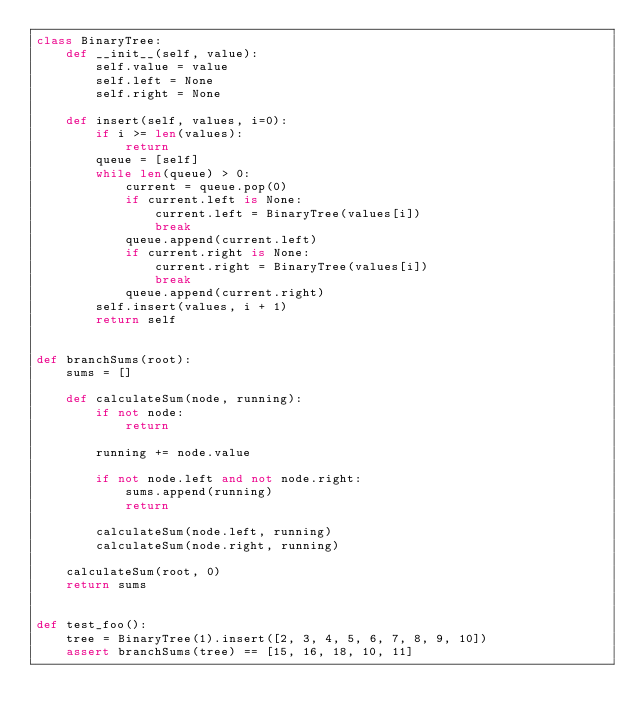Convert code to text. <code><loc_0><loc_0><loc_500><loc_500><_Python_>class BinaryTree:
    def __init__(self, value):
        self.value = value
        self.left = None
        self.right = None

    def insert(self, values, i=0):
        if i >= len(values):
            return
        queue = [self]
        while len(queue) > 0:
            current = queue.pop(0)
            if current.left is None:
                current.left = BinaryTree(values[i])
                break
            queue.append(current.left)
            if current.right is None:
                current.right = BinaryTree(values[i])
                break
            queue.append(current.right)
        self.insert(values, i + 1)
        return self


def branchSums(root):
    sums = []

    def calculateSum(node, running):
        if not node:
            return

        running += node.value

        if not node.left and not node.right:
            sums.append(running)
            return

        calculateSum(node.left, running)
        calculateSum(node.right, running)

    calculateSum(root, 0)
    return sums


def test_foo():
    tree = BinaryTree(1).insert([2, 3, 4, 5, 6, 7, 8, 9, 10])
    assert branchSums(tree) == [15, 16, 18, 10, 11]</code> 